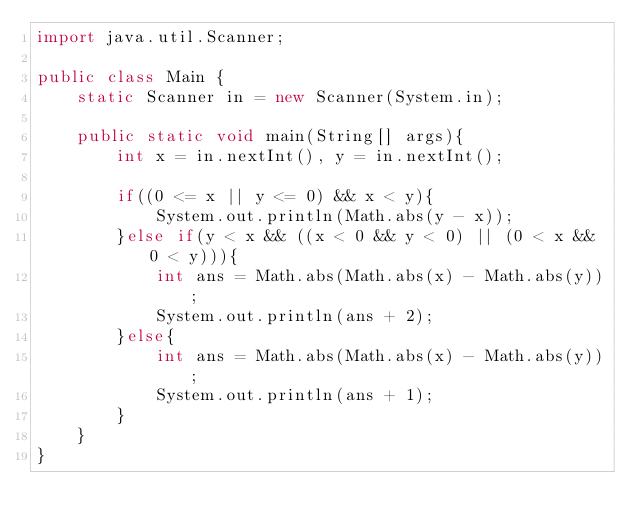<code> <loc_0><loc_0><loc_500><loc_500><_Java_>import java.util.Scanner;

public class Main {
	static Scanner in = new Scanner(System.in);
	
	public static void main(String[] args){
		int x = in.nextInt(), y = in.nextInt();
		
		if((0 <= x || y <= 0) && x < y){
			System.out.println(Math.abs(y - x));
		}else if(y < x && ((x < 0 && y < 0) || (0 < x && 0 < y))){
			int ans = Math.abs(Math.abs(x) - Math.abs(y));
			System.out.println(ans + 2);
		}else{
			int ans = Math.abs(Math.abs(x) - Math.abs(y));
			System.out.println(ans + 1);
		}
	}
}</code> 